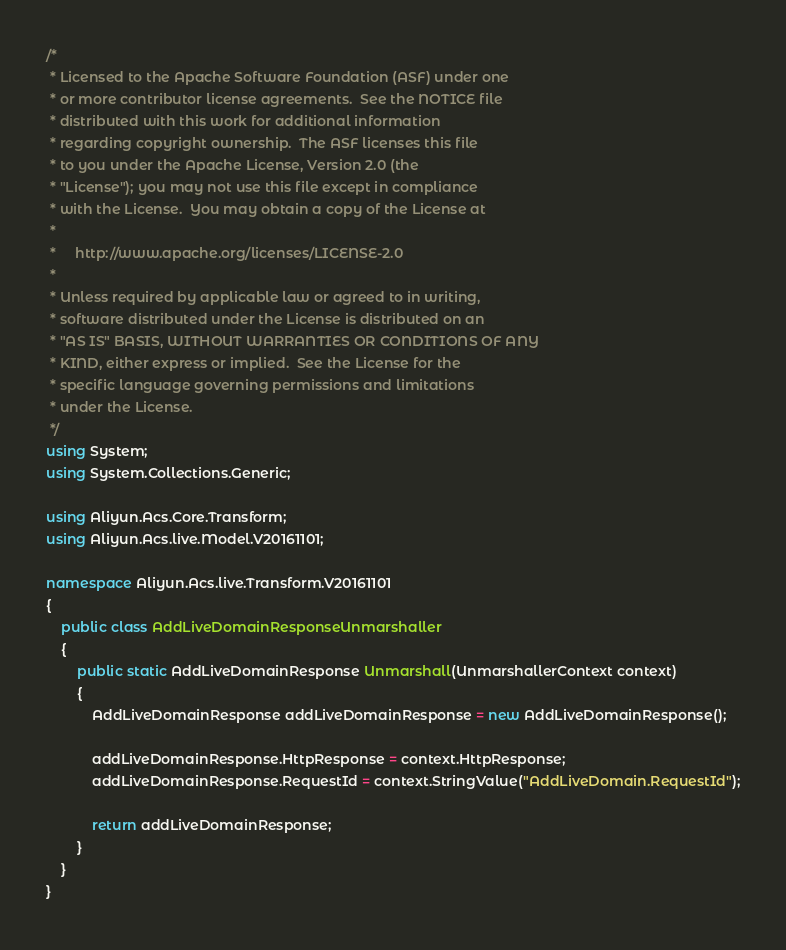Convert code to text. <code><loc_0><loc_0><loc_500><loc_500><_C#_>/*
 * Licensed to the Apache Software Foundation (ASF) under one
 * or more contributor license agreements.  See the NOTICE file
 * distributed with this work for additional information
 * regarding copyright ownership.  The ASF licenses this file
 * to you under the Apache License, Version 2.0 (the
 * "License"); you may not use this file except in compliance
 * with the License.  You may obtain a copy of the License at
 *
 *     http://www.apache.org/licenses/LICENSE-2.0
 *
 * Unless required by applicable law or agreed to in writing,
 * software distributed under the License is distributed on an
 * "AS IS" BASIS, WITHOUT WARRANTIES OR CONDITIONS OF ANY
 * KIND, either express or implied.  See the License for the
 * specific language governing permissions and limitations
 * under the License.
 */
using System;
using System.Collections.Generic;

using Aliyun.Acs.Core.Transform;
using Aliyun.Acs.live.Model.V20161101;

namespace Aliyun.Acs.live.Transform.V20161101
{
    public class AddLiveDomainResponseUnmarshaller
    {
        public static AddLiveDomainResponse Unmarshall(UnmarshallerContext context)
        {
			AddLiveDomainResponse addLiveDomainResponse = new AddLiveDomainResponse();

			addLiveDomainResponse.HttpResponse = context.HttpResponse;
			addLiveDomainResponse.RequestId = context.StringValue("AddLiveDomain.RequestId");
        
			return addLiveDomainResponse;
        }
    }
}
</code> 